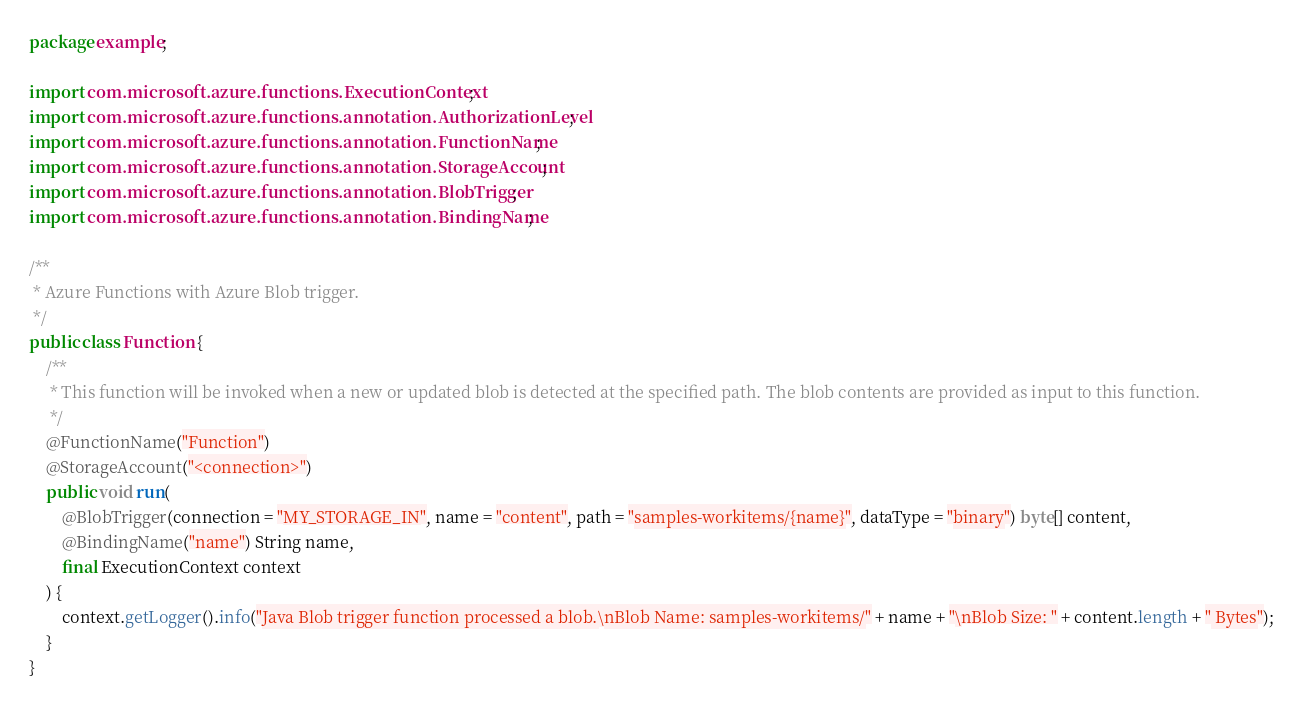Convert code to text. <code><loc_0><loc_0><loc_500><loc_500><_Java_>package example;

import com.microsoft.azure.functions.ExecutionContext;
import com.microsoft.azure.functions.annotation.AuthorizationLevel;
import com.microsoft.azure.functions.annotation.FunctionName;
import com.microsoft.azure.functions.annotation.StorageAccount;
import com.microsoft.azure.functions.annotation.BlobTrigger;
import com.microsoft.azure.functions.annotation.BindingName;

/**
 * Azure Functions with Azure Blob trigger.
 */
public class Function {
    /**
     * This function will be invoked when a new or updated blob is detected at the specified path. The blob contents are provided as input to this function.
     */
    @FunctionName("Function")
    @StorageAccount("<connection>")
    public void run(
        @BlobTrigger(connection = "MY_STORAGE_IN", name = "content", path = "samples-workitems/{name}", dataType = "binary") byte[] content,
        @BindingName("name") String name,
        final ExecutionContext context
    ) {
        context.getLogger().info("Java Blob trigger function processed a blob.\nBlob Name: samples-workitems/" + name + "\nBlob Size: " + content.length + " Bytes");
    }
}
</code> 